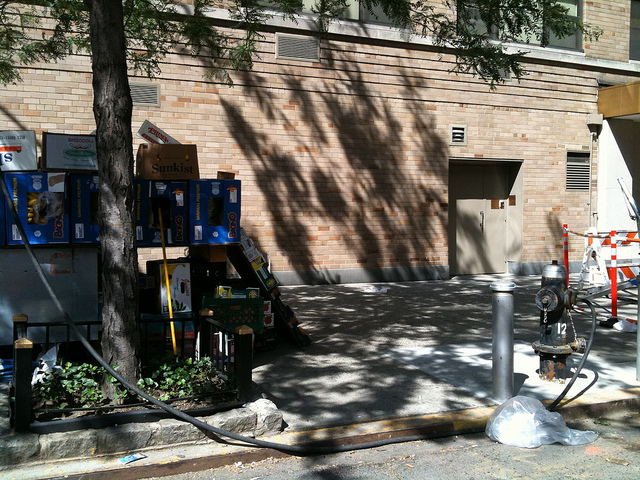Read all the text in this image. Sunkist S 